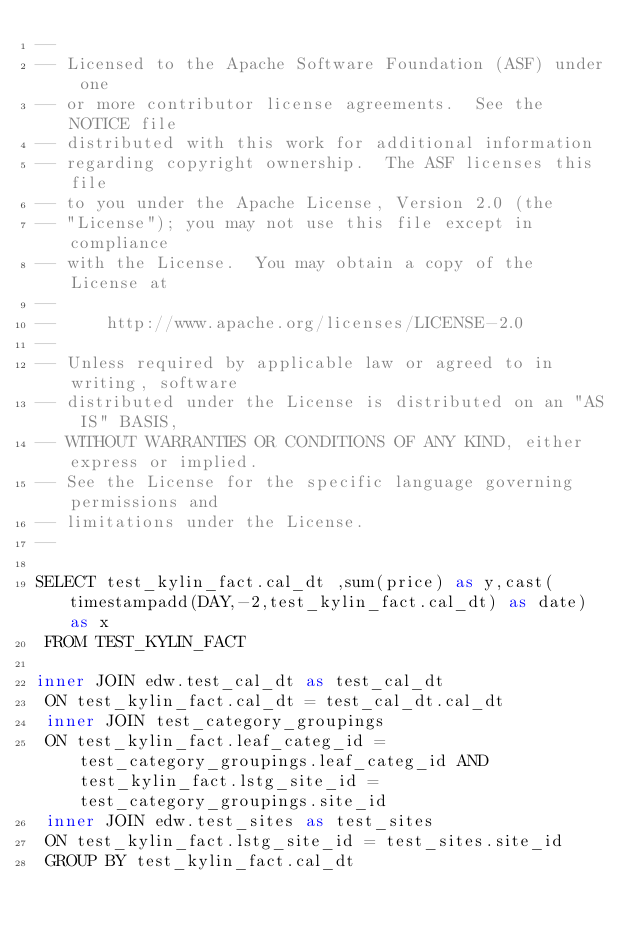Convert code to text. <code><loc_0><loc_0><loc_500><loc_500><_SQL_>--
-- Licensed to the Apache Software Foundation (ASF) under one
-- or more contributor license agreements.  See the NOTICE file
-- distributed with this work for additional information
-- regarding copyright ownership.  The ASF licenses this file
-- to you under the Apache License, Version 2.0 (the
-- "License"); you may not use this file except in compliance
-- with the License.  You may obtain a copy of the License at
--
--     http://www.apache.org/licenses/LICENSE-2.0
--
-- Unless required by applicable law or agreed to in writing, software
-- distributed under the License is distributed on an "AS IS" BASIS,
-- WITHOUT WARRANTIES OR CONDITIONS OF ANY KIND, either express or implied.
-- See the License for the specific language governing permissions and
-- limitations under the License.
--

SELECT test_kylin_fact.cal_dt ,sum(price) as y,cast(timestampadd(DAY,-2,test_kylin_fact.cal_dt) as date) as x
 FROM TEST_KYLIN_FACT 
 
inner JOIN edw.test_cal_dt as test_cal_dt
 ON test_kylin_fact.cal_dt = test_cal_dt.cal_dt
 inner JOIN test_category_groupings
 ON test_kylin_fact.leaf_categ_id = test_category_groupings.leaf_categ_id AND test_kylin_fact.lstg_site_id = test_category_groupings.site_id
 inner JOIN edw.test_sites as test_sites
 ON test_kylin_fact.lstg_site_id = test_sites.site_id
 GROUP BY test_kylin_fact.cal_dt
</code> 